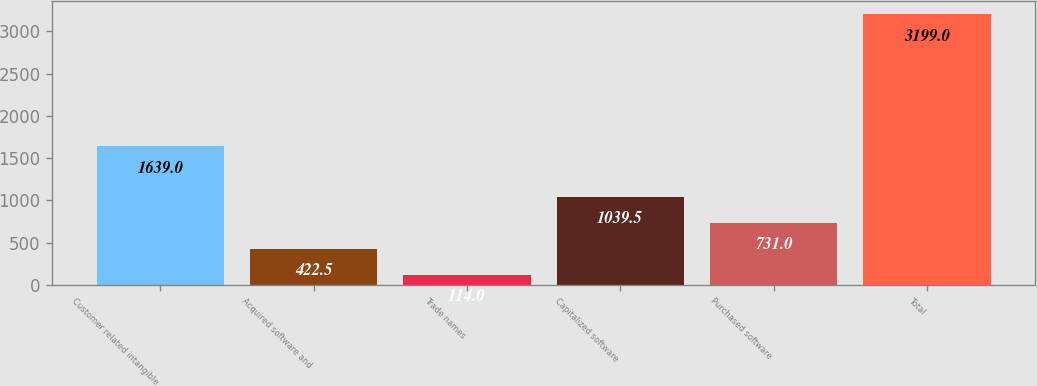Convert chart to OTSL. <chart><loc_0><loc_0><loc_500><loc_500><bar_chart><fcel>Customer related intangible<fcel>Acquired software and<fcel>Trade names<fcel>Capitalized software<fcel>Purchased software<fcel>Total<nl><fcel>1639<fcel>422.5<fcel>114<fcel>1039.5<fcel>731<fcel>3199<nl></chart> 